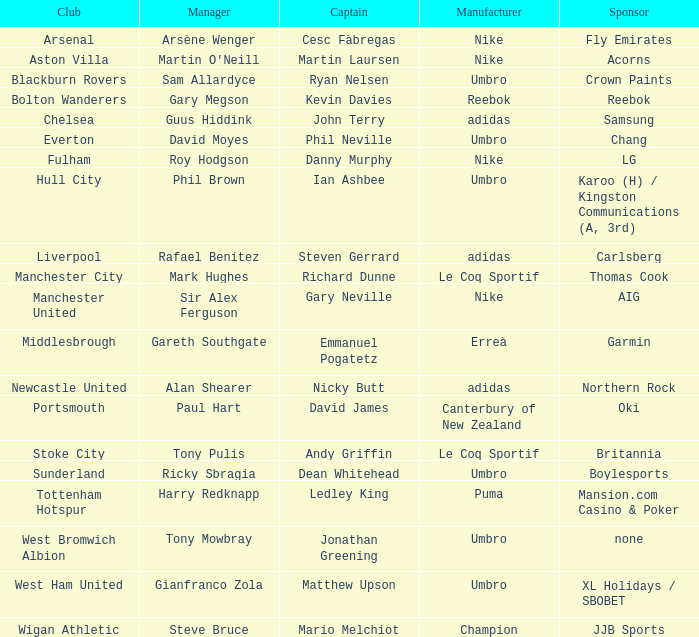What Premier League Manager has an Adidas sponsor and a Newcastle United club? Alan Shearer. Would you mind parsing the complete table? {'header': ['Club', 'Manager', 'Captain', 'Manufacturer', 'Sponsor'], 'rows': [['Arsenal', 'Arsène Wenger', 'Cesc Fàbregas', 'Nike', 'Fly Emirates'], ['Aston Villa', "Martin O'Neill", 'Martin Laursen', 'Nike', 'Acorns'], ['Blackburn Rovers', 'Sam Allardyce', 'Ryan Nelsen', 'Umbro', 'Crown Paints'], ['Bolton Wanderers', 'Gary Megson', 'Kevin Davies', 'Reebok', 'Reebok'], ['Chelsea', 'Guus Hiddink', 'John Terry', 'adidas', 'Samsung'], ['Everton', 'David Moyes', 'Phil Neville', 'Umbro', 'Chang'], ['Fulham', 'Roy Hodgson', 'Danny Murphy', 'Nike', 'LG'], ['Hull City', 'Phil Brown', 'Ian Ashbee', 'Umbro', 'Karoo (H) / Kingston Communications (A, 3rd)'], ['Liverpool', 'Rafael Benítez', 'Steven Gerrard', 'adidas', 'Carlsberg'], ['Manchester City', 'Mark Hughes', 'Richard Dunne', 'Le Coq Sportif', 'Thomas Cook'], ['Manchester United', 'Sir Alex Ferguson', 'Gary Neville', 'Nike', 'AIG'], ['Middlesbrough', 'Gareth Southgate', 'Emmanuel Pogatetz', 'Erreà', 'Garmin'], ['Newcastle United', 'Alan Shearer', 'Nicky Butt', 'adidas', 'Northern Rock'], ['Portsmouth', 'Paul Hart', 'David James', 'Canterbury of New Zealand', 'Oki'], ['Stoke City', 'Tony Pulis', 'Andy Griffin', 'Le Coq Sportif', 'Britannia'], ['Sunderland', 'Ricky Sbragia', 'Dean Whitehead', 'Umbro', 'Boylesports'], ['Tottenham Hotspur', 'Harry Redknapp', 'Ledley King', 'Puma', 'Mansion.com Casino & Poker'], ['West Bromwich Albion', 'Tony Mowbray', 'Jonathan Greening', 'Umbro', 'none'], ['West Ham United', 'Gianfranco Zola', 'Matthew Upson', 'Umbro', 'XL Holidays / SBOBET'], ['Wigan Athletic', 'Steve Bruce', 'Mario Melchiot', 'Champion', 'JJB Sports']]} 